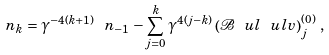Convert formula to latex. <formula><loc_0><loc_0><loc_500><loc_500>\ n _ { k } = \gamma ^ { - 4 ( k + 1 ) } \ n _ { - 1 } - \sum _ { j = 0 } ^ { k } \gamma ^ { 4 ( j - k ) } \left ( \mathcal { B } \ u l { \ u l { v } } \right ) ^ { ( 0 ) } _ { j } \, ,</formula> 